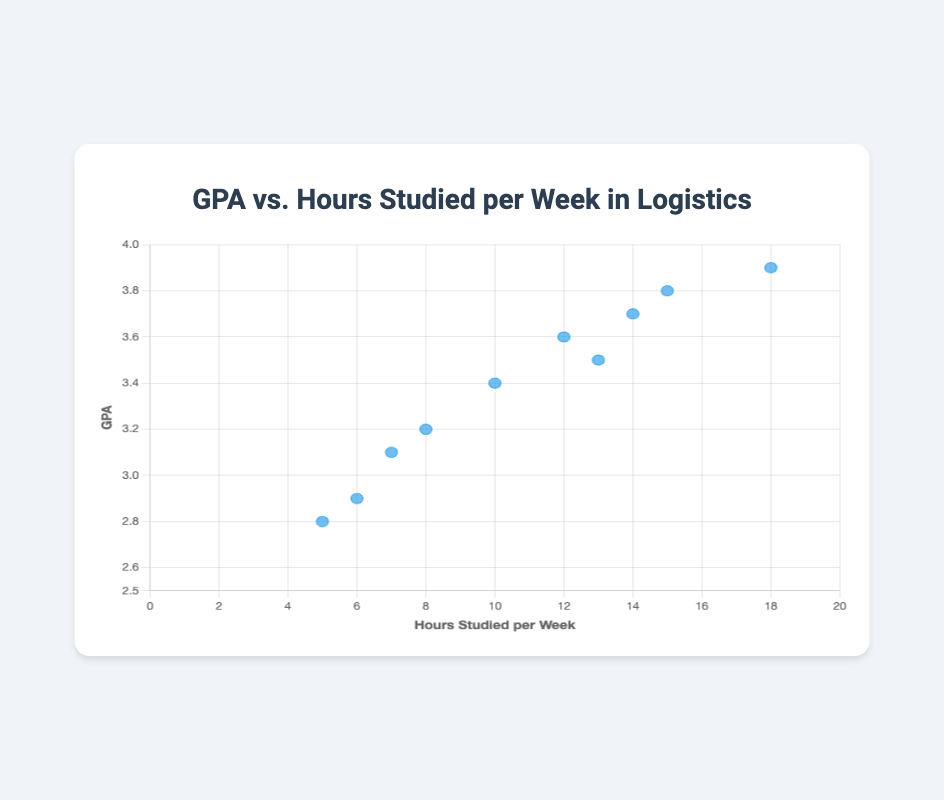How many data points are shown in the scatter plot? There are 10 students listed in the provided data, each represented by a data point in the figure.
Answer: 10 What is the title of the figure? The title is displayed at the top of the figure.
Answer: GPA vs. Hours Studied per Week in Logistics Which student has the highest GPA and how many hours do they study per week? By examining the data points, Sarah Davis has the highest GPA of 3.9 and she studies 18 hours per week.
Answer: Sarah Davis, 18 hours What is the range of the hours studied per week axis? The scatter plot’s x-axis starts at 0 and goes up to 20 hours per week.
Answer: 0 to 20 What do the data points in the scatter plot represent? Each point represents a student with their x-coordinate showing hours studied per week and y-coordinate showing GPA.
Answer: Students' hours studied per week and GPA What is the average GPA of students who study more than 10 hours per week? Students studying more than 10 hours have GPAs of 3.8, 3.6, 3.9, 3.5, and 3.7. The sum of these GPAs is 18.5. Dividing 18.5 by 5 gives 3.7.
Answer: 3.7 Which student has the lowest GPA, and what is their study time per week? David Wilson has the lowest GPA of 2.8 and studies 5 hours per week.
Answer: David Wilson, 5 hours Does studying more hours per week generally correlate with a higher GPA in this data set? By observing the data points, students who study more hours per week tend to have higher GPAs, suggesting a positive correlation.
Answer: Yes What is the difference in study time between the student with the highest GPA and the student with the lowest GPA? Sarah Davis has the highest GPA (18 hours/week) and David Wilson has the lowest GPA (5 hours/week). The difference is 18 - 5 = 13 hours.
Answer: 13 hours How many students study less than the average weekly study hours, and what are their GPAs? Average study hours = (15+12+8+18+5+13+6+14+10+7)/10 = 10.8 hours. Students studying less include Michael Smith (8), David Wilson (5), James Taylor (6), Daniel Anderson (10), and Ashley Thomas (7). Their GPAs are 3.2, 2.8, 2.9, 3.4, and 3.1 respectively.
Answer: 5 students (3.2, 2.8, 2.9, 3.4, 3.1) 